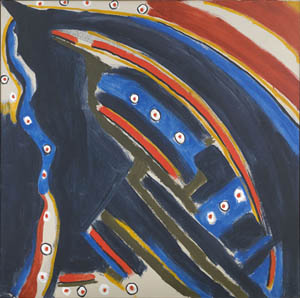What emotions do you feel this image might evoke in viewers? This image could provoke a wide range of emotions in viewers. The deep blue and black tones might evoke feelings of mystery, contemplation, or even melancholy. The abstract nature of the central shape and its stark white outline could inspire a sense of curiosity or intrigue as viewers try to interpret its meaning. The scattered dots of red, yellow, and white add a dynamic and almost cosmic element, potentially inducing a sense of wonder or excitement. Overall, the image's vivid contrasts and abstract forms encourage introspection and personal emotional responses. 